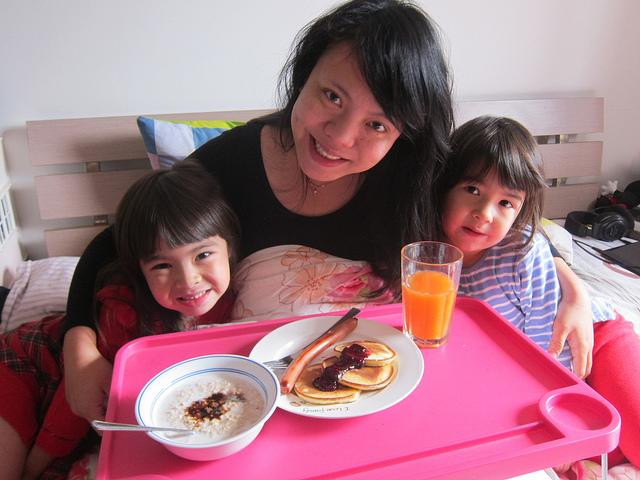How do these people know each other?

Choices:
A) teammates
B) coworkers
C) family
D) classmates family 